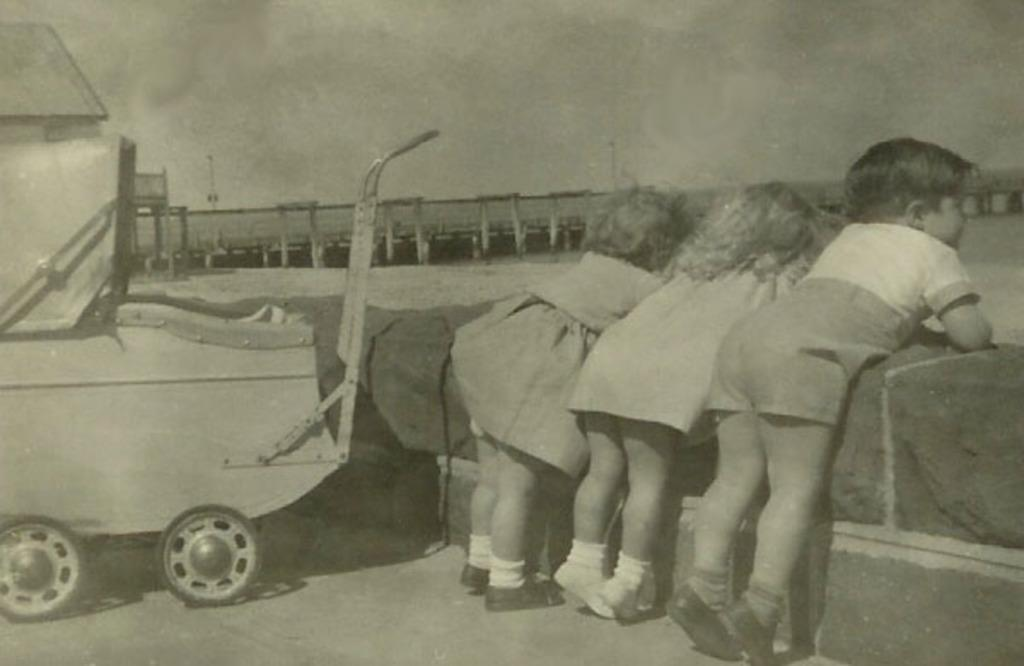What is the color scheme of the image? The image is black and white. How many kids are present in the image? There are three kids in the image. Where are the kids located in relation to other objects in the image? The kids are standing near a wall. What else can be seen in the image besides the kids? There is a vehicle in the image. What is present on the poles in the background of the image? There is something on the poles in the background of the image. Can you see any friends playing on the swing in the image? There is no swing or friends present in the image. What type of spoon is being used by the kids in the image? There are no spoons visible in the image. 